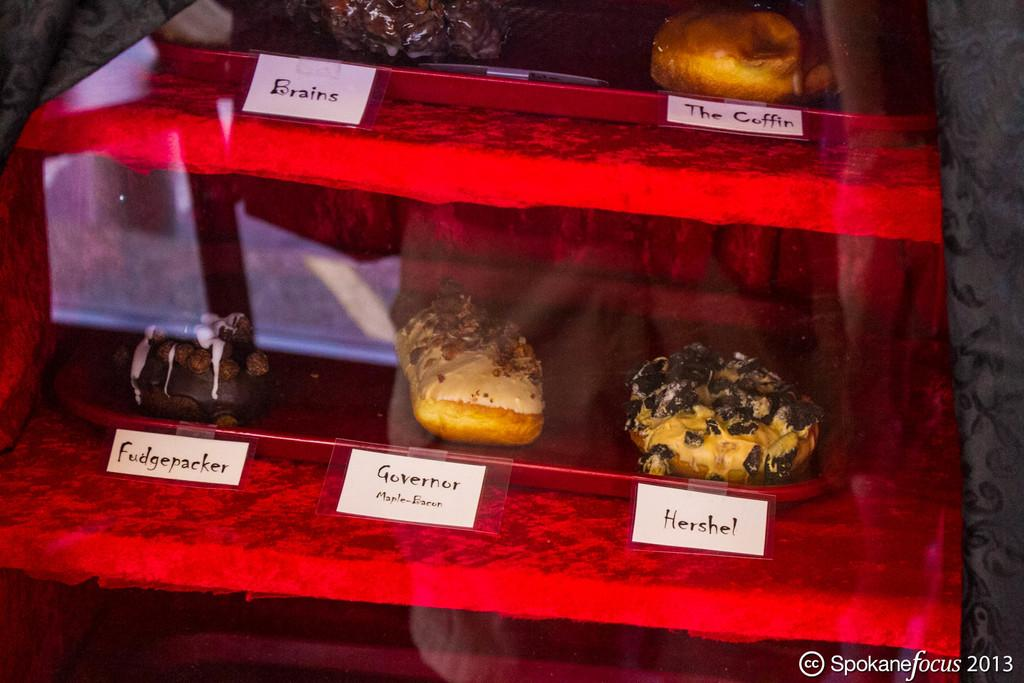<image>
Relay a brief, clear account of the picture shown. A window of pastries with one called Hershel sits on display 